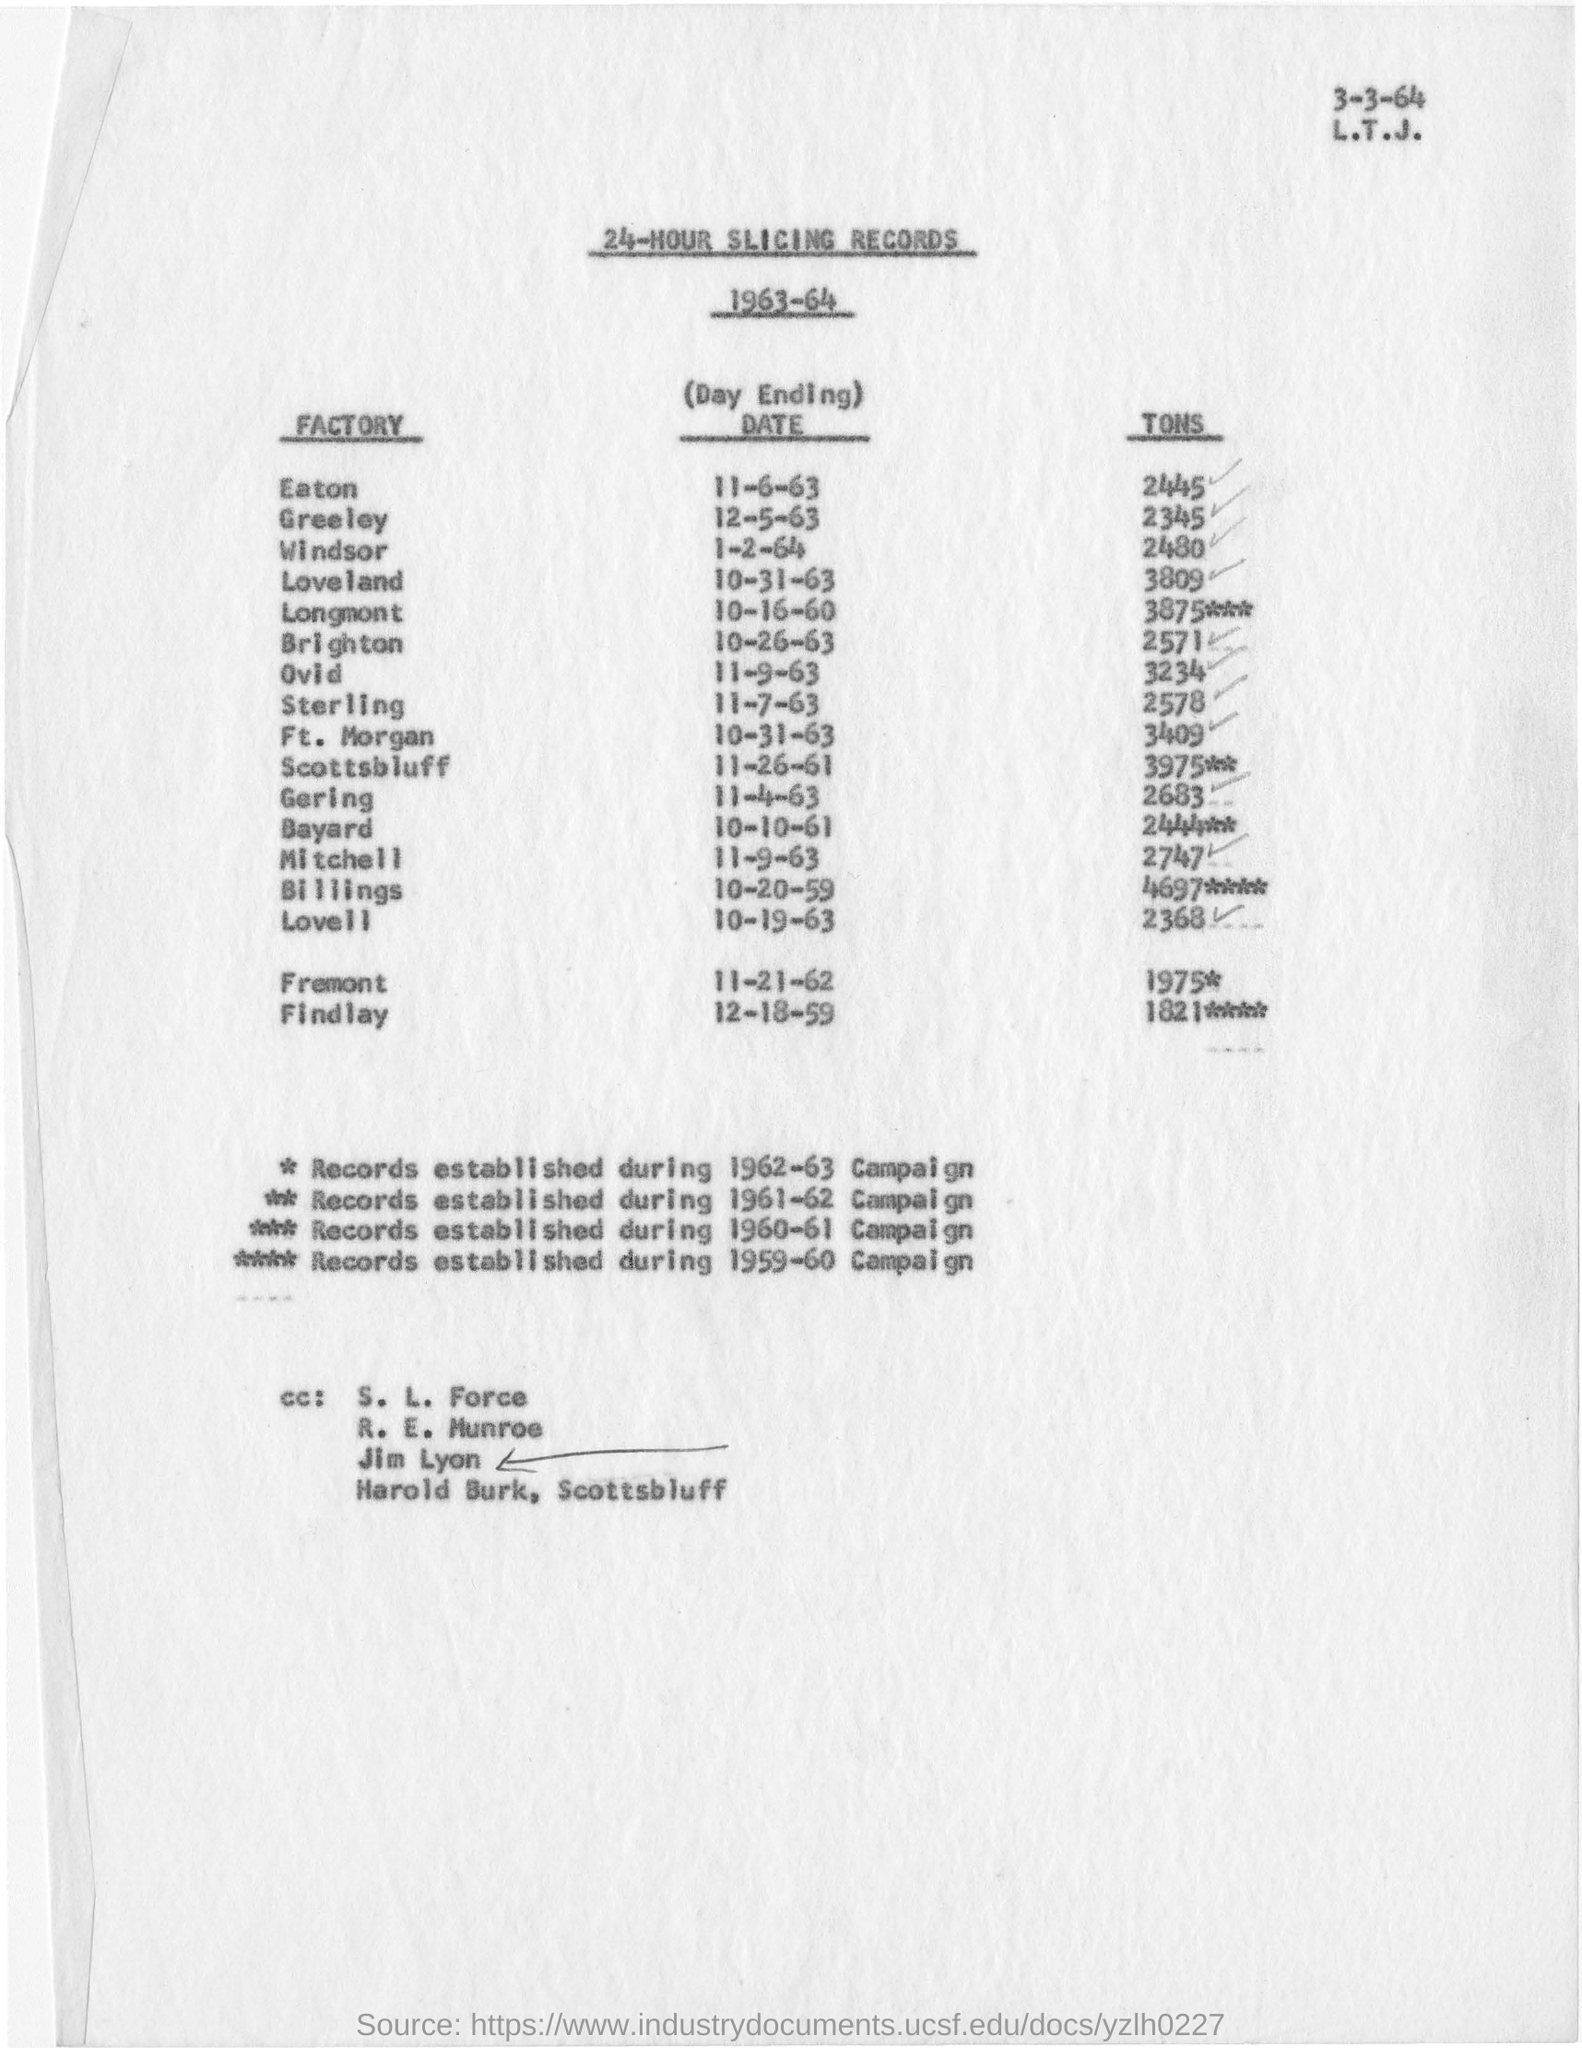Identify some key points in this picture. March 3, 1964, is the date mentioned at the top of the page. 